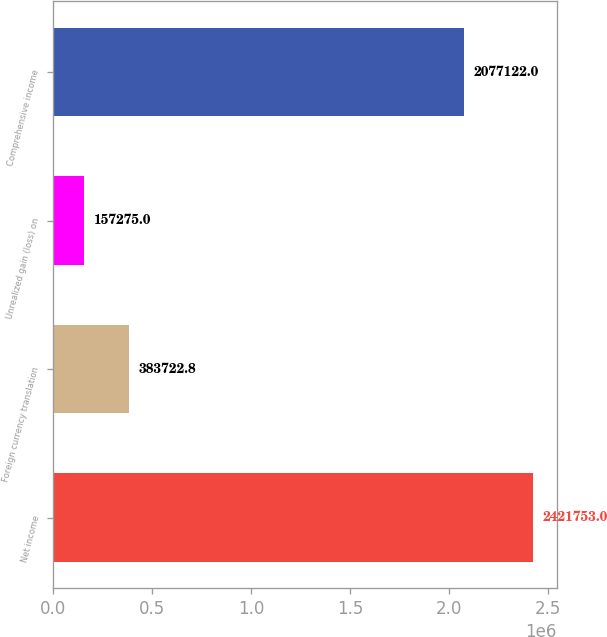<chart> <loc_0><loc_0><loc_500><loc_500><bar_chart><fcel>Net income<fcel>Foreign currency translation<fcel>Unrealized gain (loss) on<fcel>Comprehensive income<nl><fcel>2.42175e+06<fcel>383723<fcel>157275<fcel>2.07712e+06<nl></chart> 